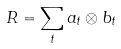Convert formula to latex. <formula><loc_0><loc_0><loc_500><loc_500>R = \sum _ { t } a _ { t } \otimes b _ { t }</formula> 